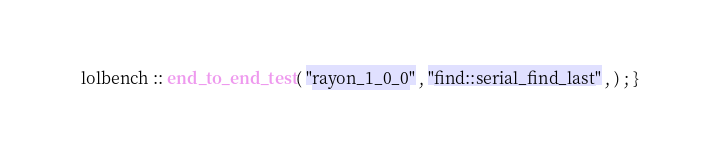Convert code to text. <code><loc_0><loc_0><loc_500><loc_500><_Rust_>lolbench :: end_to_end_test ( "rayon_1_0_0" , "find::serial_find_last" , ) ; }</code> 